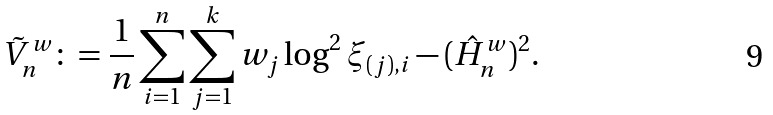<formula> <loc_0><loc_0><loc_500><loc_500>\tilde { V } _ { n } ^ { w } \colon = \frac { 1 } { n } \sum _ { i = 1 } ^ { n } \sum _ { j = 1 } ^ { k } w _ { j } \log ^ { 2 } \xi _ { ( j ) , i } - ( \hat { H } _ { n } ^ { w } ) ^ { 2 } .</formula> 